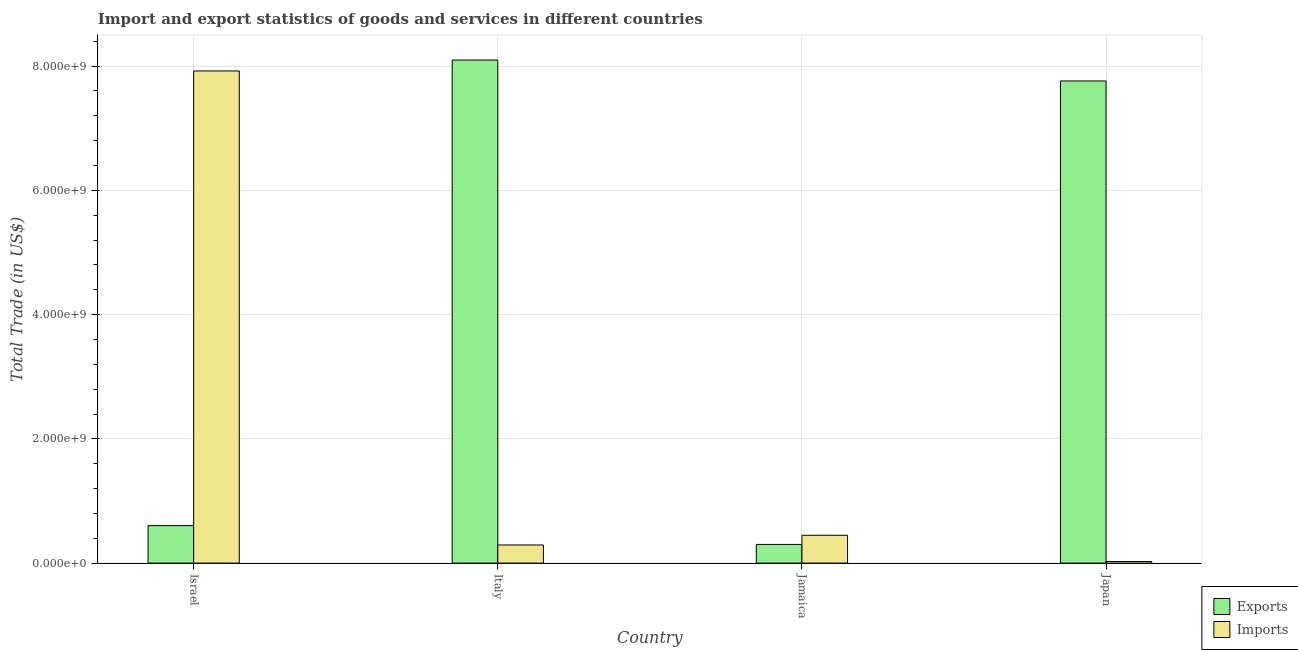How many different coloured bars are there?
Make the answer very short. 2. Are the number of bars per tick equal to the number of legend labels?
Make the answer very short. Yes. Are the number of bars on each tick of the X-axis equal?
Your answer should be compact. Yes. How many bars are there on the 4th tick from the left?
Your response must be concise. 2. What is the label of the 2nd group of bars from the left?
Ensure brevity in your answer.  Italy. What is the export of goods and services in Italy?
Your answer should be very brief. 8.10e+09. Across all countries, what is the maximum imports of goods and services?
Your answer should be very brief. 7.92e+09. Across all countries, what is the minimum imports of goods and services?
Keep it short and to the point. 2.58e+07. In which country was the export of goods and services minimum?
Make the answer very short. Jamaica. What is the total imports of goods and services in the graph?
Your response must be concise. 8.69e+09. What is the difference between the imports of goods and services in Italy and that in Japan?
Your answer should be compact. 2.66e+08. What is the difference between the export of goods and services in Israel and the imports of goods and services in Japan?
Your answer should be very brief. 5.78e+08. What is the average export of goods and services per country?
Offer a very short reply. 4.19e+09. What is the difference between the imports of goods and services and export of goods and services in Italy?
Your response must be concise. -7.81e+09. What is the ratio of the imports of goods and services in Italy to that in Japan?
Your answer should be very brief. 11.33. What is the difference between the highest and the second highest imports of goods and services?
Your answer should be compact. 7.47e+09. What is the difference between the highest and the lowest imports of goods and services?
Give a very brief answer. 7.90e+09. In how many countries, is the export of goods and services greater than the average export of goods and services taken over all countries?
Ensure brevity in your answer.  2. Is the sum of the imports of goods and services in Italy and Japan greater than the maximum export of goods and services across all countries?
Keep it short and to the point. No. What does the 2nd bar from the left in Italy represents?
Make the answer very short. Imports. What does the 2nd bar from the right in Japan represents?
Give a very brief answer. Exports. Does the graph contain any zero values?
Provide a succinct answer. No. How many legend labels are there?
Your answer should be compact. 2. What is the title of the graph?
Your answer should be compact. Import and export statistics of goods and services in different countries. Does "Primary" appear as one of the legend labels in the graph?
Your answer should be very brief. No. What is the label or title of the X-axis?
Make the answer very short. Country. What is the label or title of the Y-axis?
Keep it short and to the point. Total Trade (in US$). What is the Total Trade (in US$) of Exports in Israel?
Offer a terse response. 6.04e+08. What is the Total Trade (in US$) of Imports in Israel?
Make the answer very short. 7.92e+09. What is the Total Trade (in US$) in Exports in Italy?
Ensure brevity in your answer.  8.10e+09. What is the Total Trade (in US$) of Imports in Italy?
Your answer should be very brief. 2.92e+08. What is the Total Trade (in US$) of Exports in Jamaica?
Keep it short and to the point. 3.00e+08. What is the Total Trade (in US$) in Imports in Jamaica?
Offer a terse response. 4.48e+08. What is the Total Trade (in US$) of Exports in Japan?
Give a very brief answer. 7.76e+09. What is the Total Trade (in US$) in Imports in Japan?
Offer a terse response. 2.58e+07. Across all countries, what is the maximum Total Trade (in US$) of Exports?
Ensure brevity in your answer.  8.10e+09. Across all countries, what is the maximum Total Trade (in US$) of Imports?
Provide a short and direct response. 7.92e+09. Across all countries, what is the minimum Total Trade (in US$) of Exports?
Keep it short and to the point. 3.00e+08. Across all countries, what is the minimum Total Trade (in US$) of Imports?
Your response must be concise. 2.58e+07. What is the total Total Trade (in US$) in Exports in the graph?
Offer a very short reply. 1.68e+1. What is the total Total Trade (in US$) in Imports in the graph?
Your answer should be compact. 8.69e+09. What is the difference between the Total Trade (in US$) in Exports in Israel and that in Italy?
Provide a short and direct response. -7.49e+09. What is the difference between the Total Trade (in US$) of Imports in Israel and that in Italy?
Offer a terse response. 7.63e+09. What is the difference between the Total Trade (in US$) in Exports in Israel and that in Jamaica?
Ensure brevity in your answer.  3.03e+08. What is the difference between the Total Trade (in US$) in Imports in Israel and that in Jamaica?
Your answer should be compact. 7.47e+09. What is the difference between the Total Trade (in US$) of Exports in Israel and that in Japan?
Make the answer very short. -7.16e+09. What is the difference between the Total Trade (in US$) of Imports in Israel and that in Japan?
Ensure brevity in your answer.  7.90e+09. What is the difference between the Total Trade (in US$) in Exports in Italy and that in Jamaica?
Make the answer very short. 7.80e+09. What is the difference between the Total Trade (in US$) of Imports in Italy and that in Jamaica?
Provide a succinct answer. -1.56e+08. What is the difference between the Total Trade (in US$) in Exports in Italy and that in Japan?
Make the answer very short. 3.37e+08. What is the difference between the Total Trade (in US$) in Imports in Italy and that in Japan?
Provide a short and direct response. 2.66e+08. What is the difference between the Total Trade (in US$) in Exports in Jamaica and that in Japan?
Keep it short and to the point. -7.46e+09. What is the difference between the Total Trade (in US$) of Imports in Jamaica and that in Japan?
Keep it short and to the point. 4.22e+08. What is the difference between the Total Trade (in US$) of Exports in Israel and the Total Trade (in US$) of Imports in Italy?
Give a very brief answer. 3.12e+08. What is the difference between the Total Trade (in US$) in Exports in Israel and the Total Trade (in US$) in Imports in Jamaica?
Provide a short and direct response. 1.55e+08. What is the difference between the Total Trade (in US$) of Exports in Israel and the Total Trade (in US$) of Imports in Japan?
Ensure brevity in your answer.  5.78e+08. What is the difference between the Total Trade (in US$) of Exports in Italy and the Total Trade (in US$) of Imports in Jamaica?
Provide a succinct answer. 7.65e+09. What is the difference between the Total Trade (in US$) of Exports in Italy and the Total Trade (in US$) of Imports in Japan?
Ensure brevity in your answer.  8.07e+09. What is the difference between the Total Trade (in US$) of Exports in Jamaica and the Total Trade (in US$) of Imports in Japan?
Provide a succinct answer. 2.75e+08. What is the average Total Trade (in US$) in Exports per country?
Keep it short and to the point. 4.19e+09. What is the average Total Trade (in US$) of Imports per country?
Make the answer very short. 2.17e+09. What is the difference between the Total Trade (in US$) in Exports and Total Trade (in US$) in Imports in Israel?
Ensure brevity in your answer.  -7.32e+09. What is the difference between the Total Trade (in US$) of Exports and Total Trade (in US$) of Imports in Italy?
Your answer should be compact. 7.81e+09. What is the difference between the Total Trade (in US$) of Exports and Total Trade (in US$) of Imports in Jamaica?
Provide a succinct answer. -1.48e+08. What is the difference between the Total Trade (in US$) in Exports and Total Trade (in US$) in Imports in Japan?
Your answer should be very brief. 7.74e+09. What is the ratio of the Total Trade (in US$) of Exports in Israel to that in Italy?
Give a very brief answer. 0.07. What is the ratio of the Total Trade (in US$) in Imports in Israel to that in Italy?
Make the answer very short. 27.15. What is the ratio of the Total Trade (in US$) of Exports in Israel to that in Jamaica?
Provide a succinct answer. 2.01. What is the ratio of the Total Trade (in US$) in Imports in Israel to that in Jamaica?
Give a very brief answer. 17.67. What is the ratio of the Total Trade (in US$) of Exports in Israel to that in Japan?
Provide a succinct answer. 0.08. What is the ratio of the Total Trade (in US$) in Imports in Israel to that in Japan?
Provide a succinct answer. 307.54. What is the ratio of the Total Trade (in US$) in Exports in Italy to that in Jamaica?
Provide a short and direct response. 26.95. What is the ratio of the Total Trade (in US$) of Imports in Italy to that in Jamaica?
Ensure brevity in your answer.  0.65. What is the ratio of the Total Trade (in US$) of Exports in Italy to that in Japan?
Your answer should be compact. 1.04. What is the ratio of the Total Trade (in US$) in Imports in Italy to that in Japan?
Ensure brevity in your answer.  11.33. What is the ratio of the Total Trade (in US$) of Exports in Jamaica to that in Japan?
Give a very brief answer. 0.04. What is the ratio of the Total Trade (in US$) in Imports in Jamaica to that in Japan?
Offer a terse response. 17.4. What is the difference between the highest and the second highest Total Trade (in US$) of Exports?
Make the answer very short. 3.37e+08. What is the difference between the highest and the second highest Total Trade (in US$) of Imports?
Give a very brief answer. 7.47e+09. What is the difference between the highest and the lowest Total Trade (in US$) of Exports?
Make the answer very short. 7.80e+09. What is the difference between the highest and the lowest Total Trade (in US$) in Imports?
Your response must be concise. 7.90e+09. 